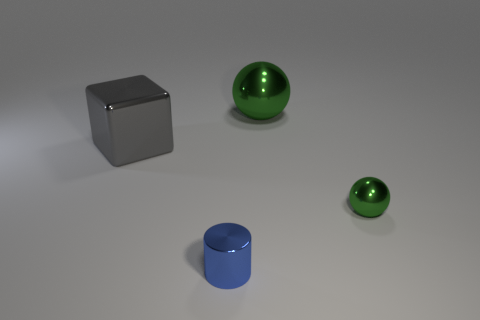What color is the small metal object on the left side of the thing behind the big gray thing?
Make the answer very short. Blue. Is the size of the gray metal thing the same as the blue thing?
Your response must be concise. No. What is the color of the thing that is in front of the big gray cube and right of the small cylinder?
Your answer should be very brief. Green. The blue thing has what size?
Offer a terse response. Small. Is the color of the ball behind the tiny green sphere the same as the tiny ball?
Give a very brief answer. Yes. Is the number of small shiny objects right of the big gray shiny cube greater than the number of blue things that are behind the blue metal object?
Provide a succinct answer. Yes. Are there more tiny green shiny balls than big brown shiny cylinders?
Provide a succinct answer. Yes. There is a thing that is both left of the big ball and behind the blue metallic thing; what size is it?
Offer a very short reply. Large. The small green object is what shape?
Give a very brief answer. Sphere. Are there more spheres behind the big gray cube than green metallic cubes?
Ensure brevity in your answer.  Yes. 